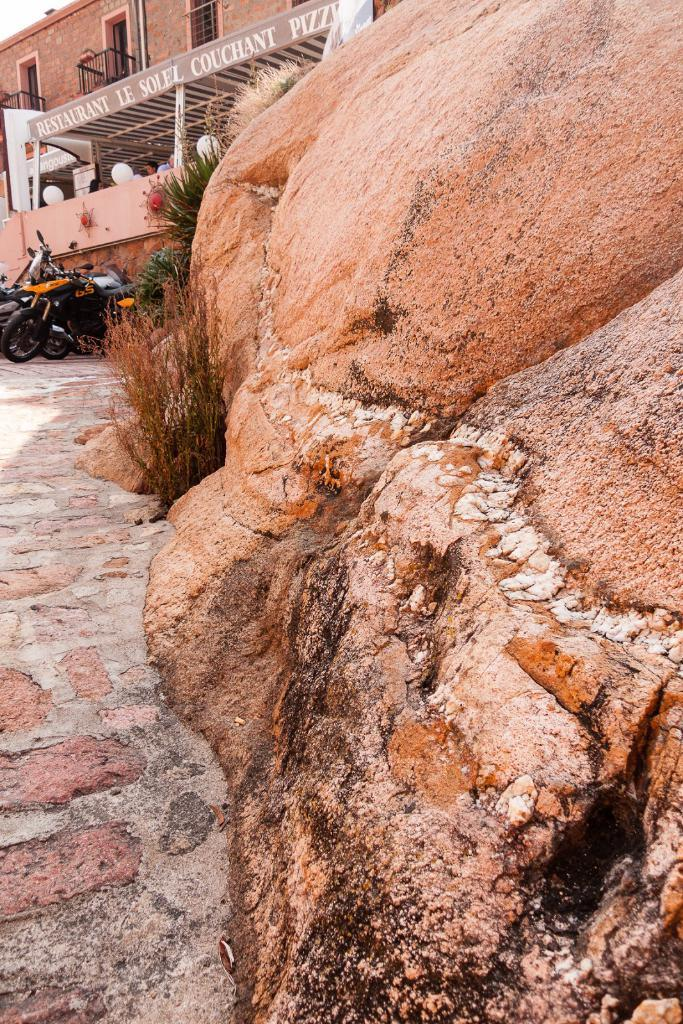What type of natural elements can be seen in the image? There are rocks in the image. What is growing near the rocks? There are plants near the rocks. What type of structure is visible in the background? There is a building with windows in the background. What architectural features can be seen on the building? The building has balconies. What type of signage is present on the building? The building has name boards. What type of vehicles are near the building? There are motorcycles near the building. How does the airport contribute to the hope of the people in the image? There is no airport present in the image, so it cannot contribute to the hope of the people. 